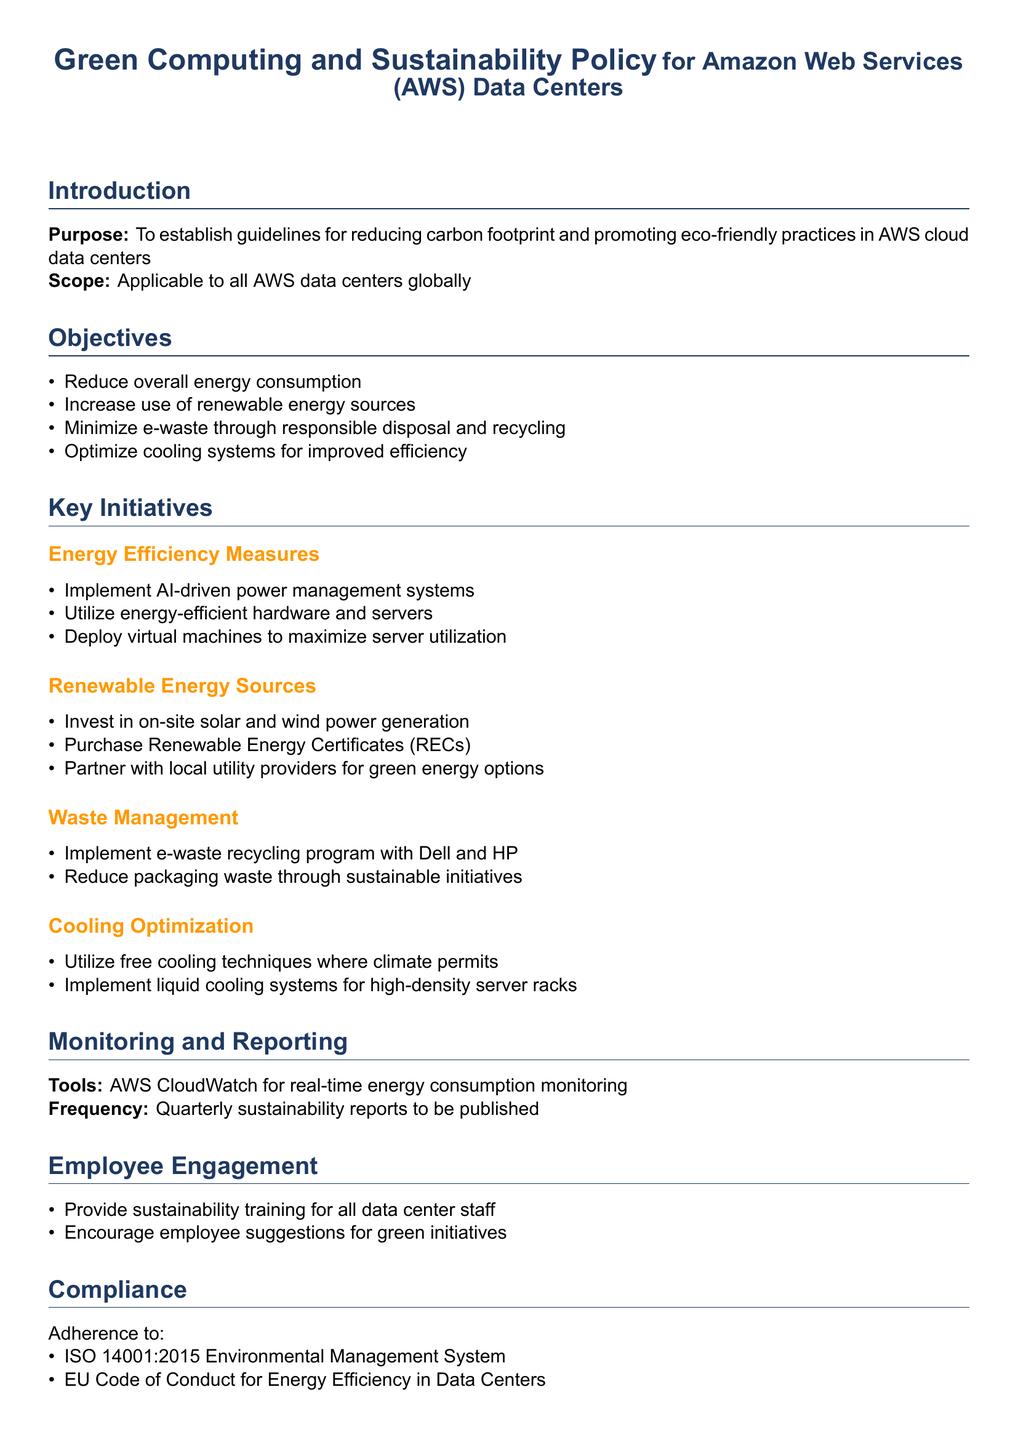What is the purpose of the policy? The purpose is to establish guidelines for reducing carbon footprint and promoting eco-friendly practices in AWS cloud data centers.
Answer: To establish guidelines for reducing carbon footprint and promoting eco-friendly practices in AWS cloud data centers Which organization does this policy apply to? The policy applies to all AWS data centers globally.
Answer: AWS data centers globally What is one objective of the policy? One objective is to increase the use of renewable energy sources.
Answer: Increase use of renewable energy sources How often are sustainability reports published? The frequency of sustainability reports is quarterly.
Answer: Quarterly What tool is used for monitoring energy consumption? AWS CloudWatch is the tool used for monitoring energy consumption.
Answer: AWS CloudWatch What type of partnerships does AWS seek for renewable energy? AWS seeks partnerships with local utility providers for green energy options.
Answer: Local utility providers What is the frequency of the policy review? The frequency of the policy review is annual.
Answer: Annual Which environmental management standard does AWS comply with? AWS complies with ISO 14001:2015 Environmental Management System.
Answer: ISO 14001:2015 What type of cooling systems are implemented for high-density server racks? Liquid cooling systems are implemented for high-density server racks.
Answer: Liquid cooling systems 